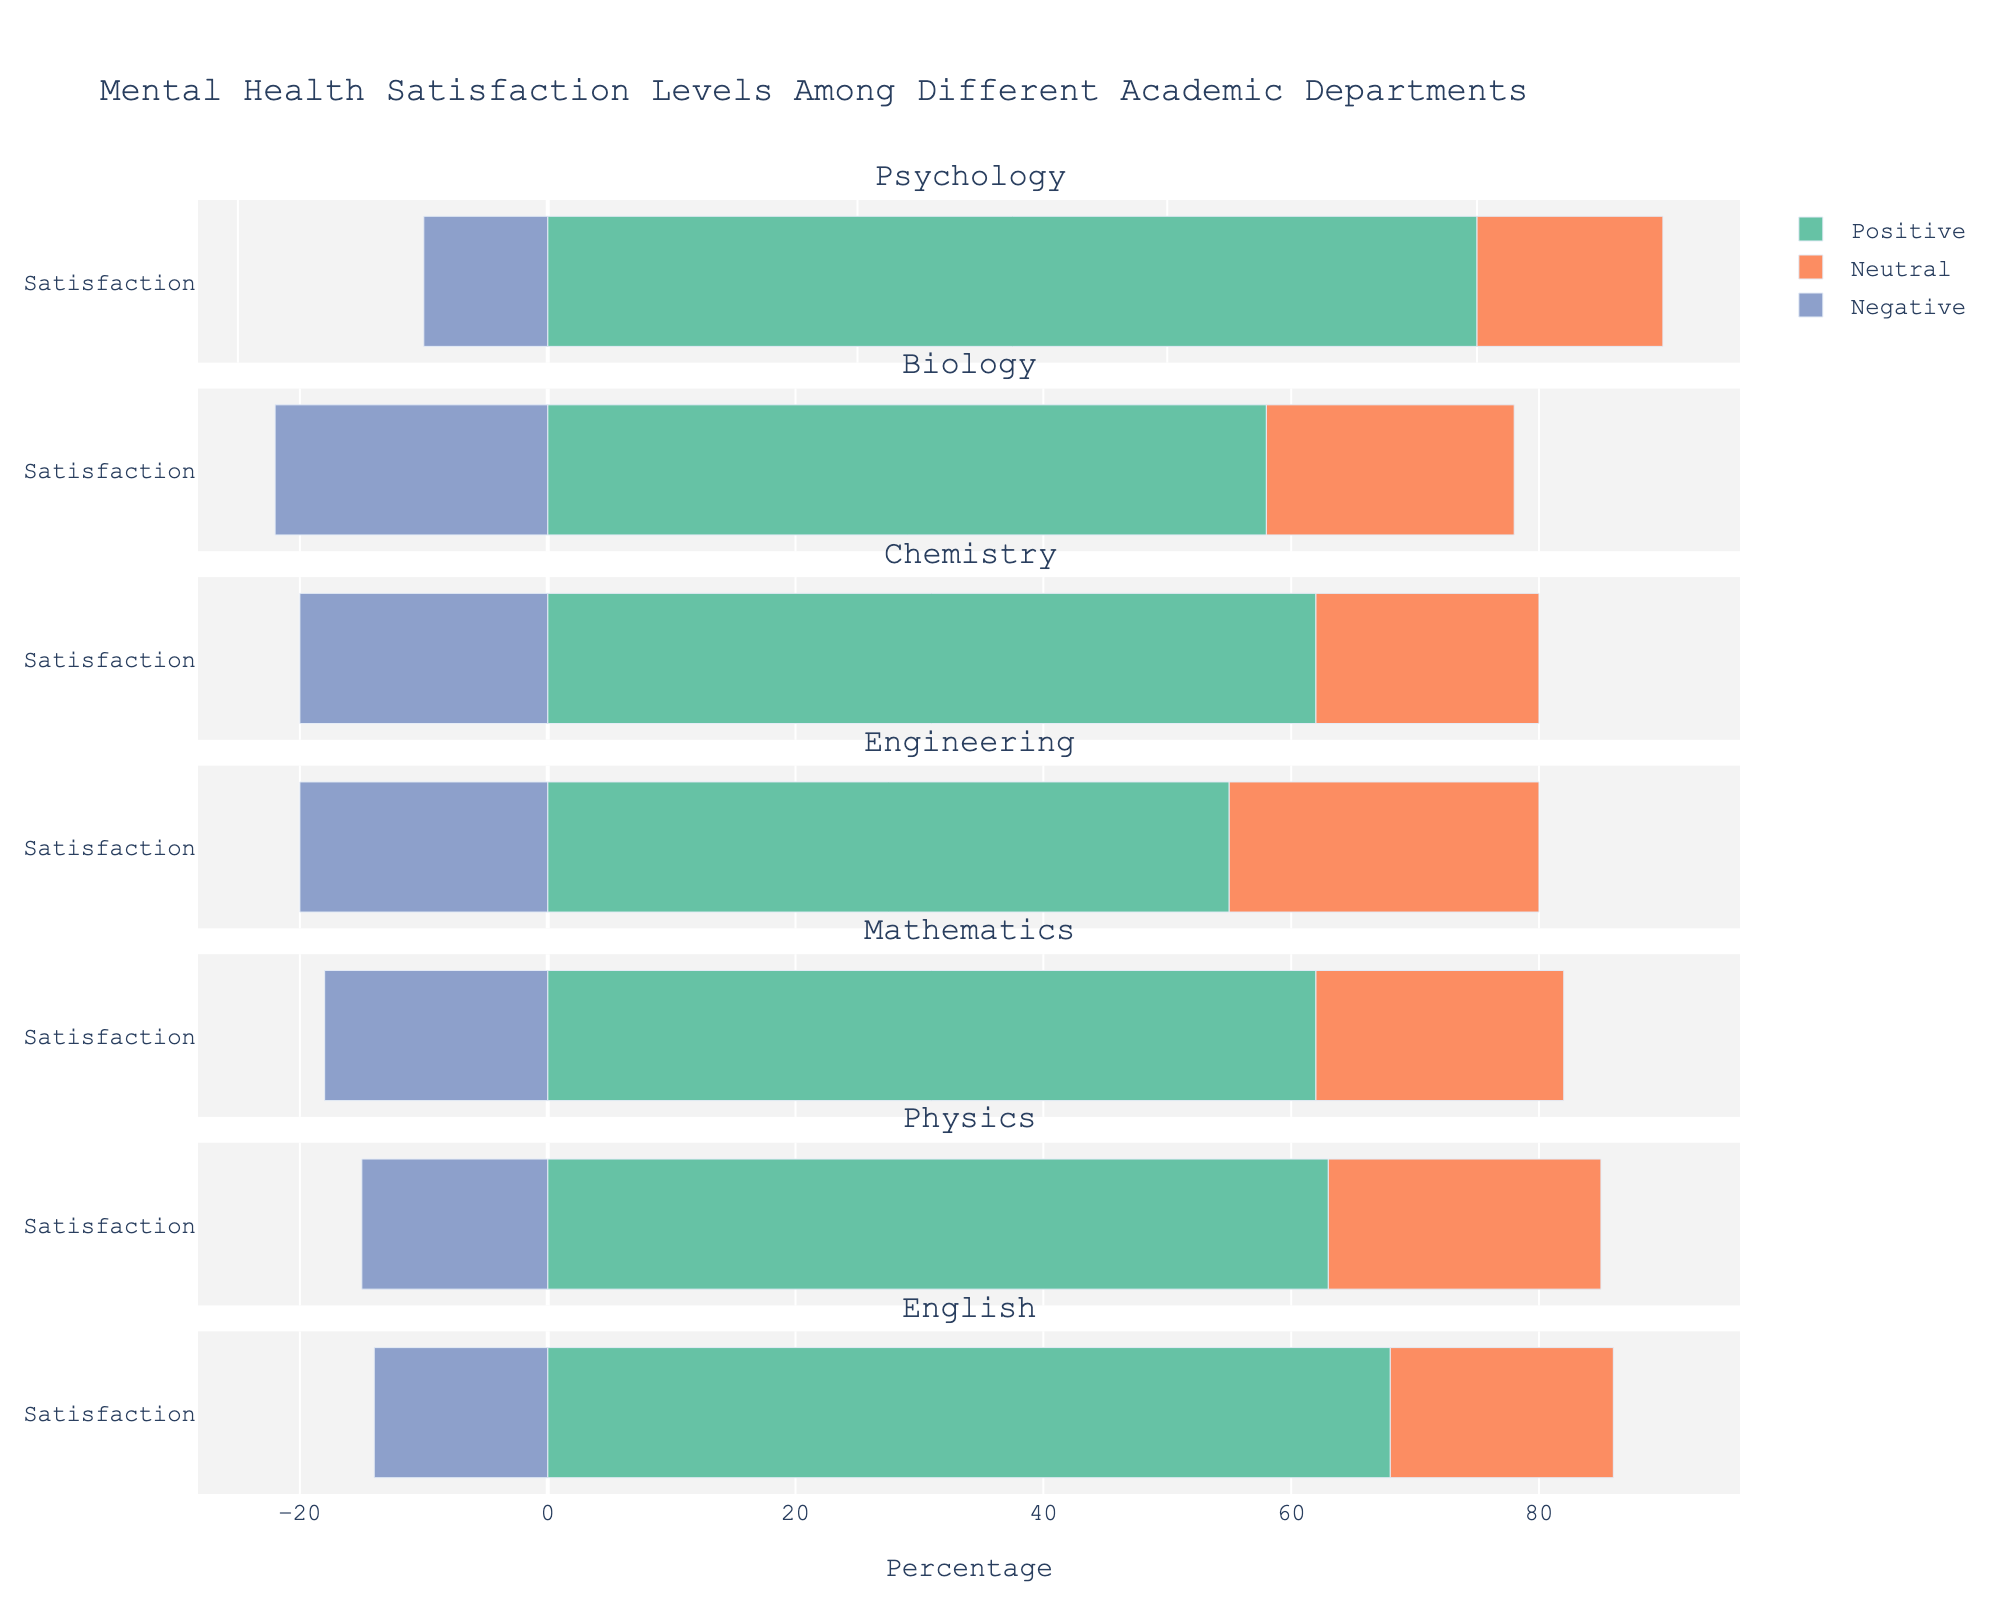What percentage of satisfaction is categorized as "Positive" for the Psychology department? Positive satisfaction levels include "Very Satisfied" and "Satisfied". For Psychology, the percentages are 40% and 35% respectively. Adding them gives 40 + 35 = 75%
Answer: 75% Which academic department has the highest negative satisfaction percentage? Negative satisfaction levels include "Dissatisfied" and "Very Dissatisfied". For each department, the totals are: Psychology: 7 + 3 = 10%, Biology: 15 + 7 = 22%, Chemistry: 12 + 8 = 20%, Engineering: 14 + 6 = 20%, Mathematics: 10 + 8 = 18%, Physics: 10 + 5 = 15%, English: 9 + 5 = 14%. The highest among these is Biology with 22%
Answer: Biology In which department is the neutral satisfaction level the highest? The neutral satisfaction percentages for each department are: Psychology: 15%, Biology: 20%, Chemistry: 18%, Engineering: 25%, Mathematics: 20%, Physics: 22%, English: 18%. The highest is in Engineering with 25%
Answer: Engineering How does the "Very Satisfied" percentage in the Mathematics department compare to that in the Biology department? The "Very Satisfied" percentage for Mathematics is 30%, while for Biology it is 28%. 30% is greater than 28%
Answer: Mathematics What is the combined percentage of "Very Satisfied" and "Neutral" responses for the Physics department? The "Very Satisfied" and "Neutral" percentages for Physics are 27% and 22%. Adding them together gives 27 + 22 = 49%
Answer: 49% Which two departments have the closest percentage of "Satisfied" responses? The "Satisfied" percentages are: Psychology: 35%, Biology: 30%, Chemistry: 37%, Engineering: 33%, Mathematics: 32%, Physics: 36%, English: 33%. The closest are Engineering and English, both at 33%
Answer: Engineering and English What is the difference in the negative satisfaction percentage between Chemistry and English departments? The negative satisfaction percentages are: Chemistry: 12 + 8 = 20%, English: 9 + 5 = 14%. The difference is 20 - 14 = 6%
Answer: 6% Among the departments, which has the lowest "Positive" percentage and what value is it? "Positive" percentages are: Psychology: 40 + 35 = 75%, Biology: 28 + 30 = 58%, Chemistry: 25 + 37 = 62%, Engineering: 22 + 33 = 55%, Mathematics: 30 + 32 = 62%, Physics: 27 + 36 = 63%, English: 35 + 33 = 68%. The lowest is Engineering at 55%
Answer: Engineering, 55% How much higher is the "Very Dissatisfied" percentage in Chemistry compared to that in Physics? The "Very Dissatisfied" percentage is 8% for Chemistry and 5% for Physics. The difference is 8 - 5 = 3%
Answer: 3% What is the average percentage of "Very Satisfied" responses across all departments? To find the average, sum the "Very Satisfied" percentages of all departments (40 + 28 + 25 + 22 + 30 + 27 + 35 = 207) and divide by the number of departments (7). So, the average is 207 / 7 = 29.57%
Answer: 29.57% 